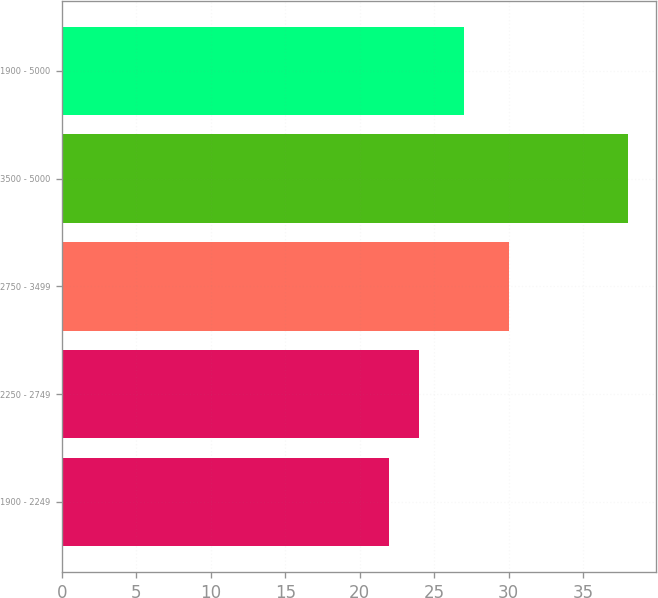Convert chart. <chart><loc_0><loc_0><loc_500><loc_500><bar_chart><fcel>1900 - 2249<fcel>2250 - 2749<fcel>2750 - 3499<fcel>3500 - 5000<fcel>1900 - 5000<nl><fcel>22<fcel>24<fcel>30<fcel>38<fcel>27<nl></chart> 